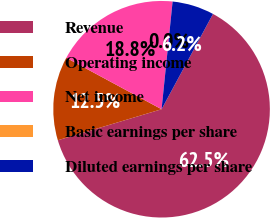Convert chart to OTSL. <chart><loc_0><loc_0><loc_500><loc_500><pie_chart><fcel>Revenue<fcel>Operating income<fcel>Net income<fcel>Basic earnings per share<fcel>Diluted earnings per share<nl><fcel>62.5%<fcel>12.5%<fcel>18.75%<fcel>0.0%<fcel>6.25%<nl></chart> 